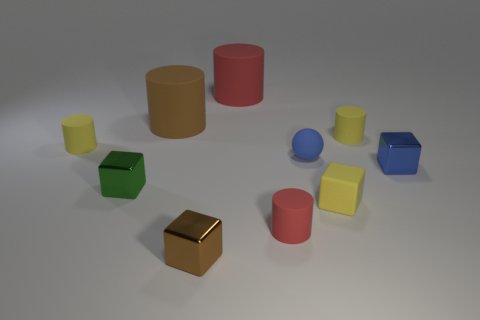How many things are both behind the tiny brown thing and in front of the big red rubber thing?
Your answer should be compact. 8. What is the material of the brown thing that is in front of the tiny green metallic cube?
Offer a very short reply. Metal. How many tiny cylinders have the same color as the rubber cube?
Provide a succinct answer. 2. The blue object that is the same material as the big red thing is what size?
Give a very brief answer. Small. How many things are yellow rubber cylinders or small matte balls?
Give a very brief answer. 3. What is the color of the tiny cylinder left of the small brown object?
Offer a terse response. Yellow. There is another red matte object that is the same shape as the big red thing; what is its size?
Your response must be concise. Small. What number of objects are either cylinders left of the tiny green shiny object or tiny yellow rubber things in front of the blue sphere?
Provide a short and direct response. 2. What is the size of the cylinder that is to the left of the tiny brown metal block and to the right of the tiny green metal cube?
Provide a succinct answer. Large. There is a small red matte object; does it have the same shape as the small brown thing that is in front of the green shiny object?
Your response must be concise. No. 